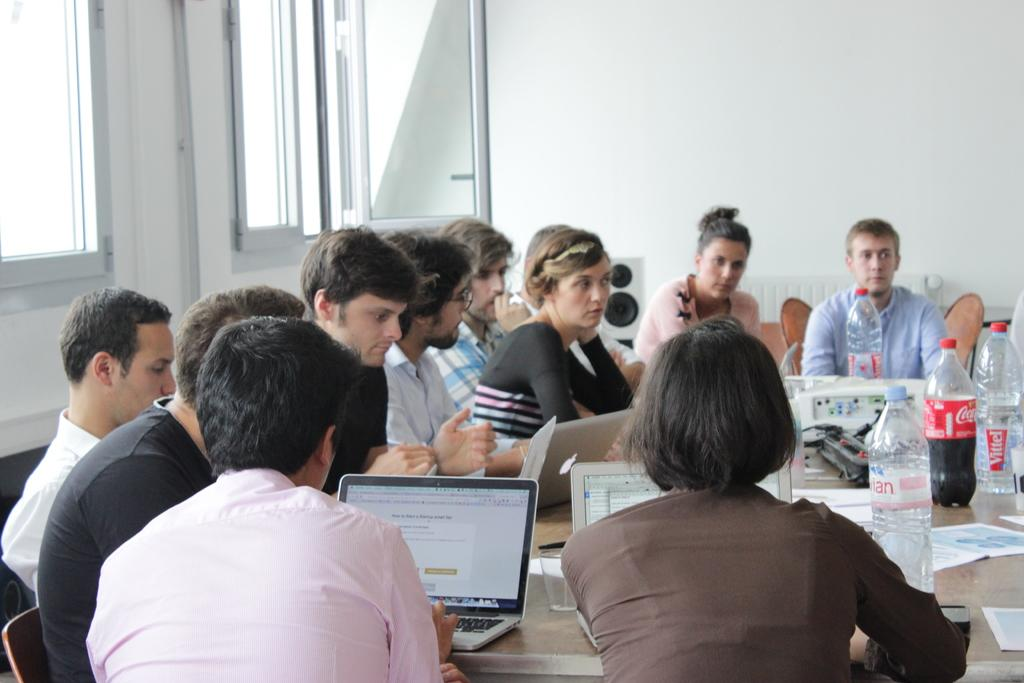How many people are in the image? There is a group of people in the image. What are the people doing in the image? The people are sitting on a chair, and three of them are working on a laptop. What type of furniture is in the image? There is a wooden table in the image. What items are on the table? Laptops and bottles are on the table. What is the best route to take for the upcoming vacation in the image? There is no information about a vacation or a route in the image. 